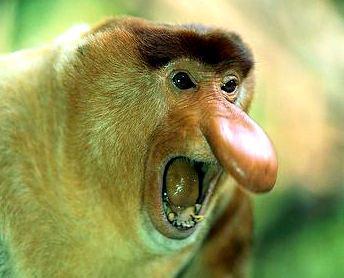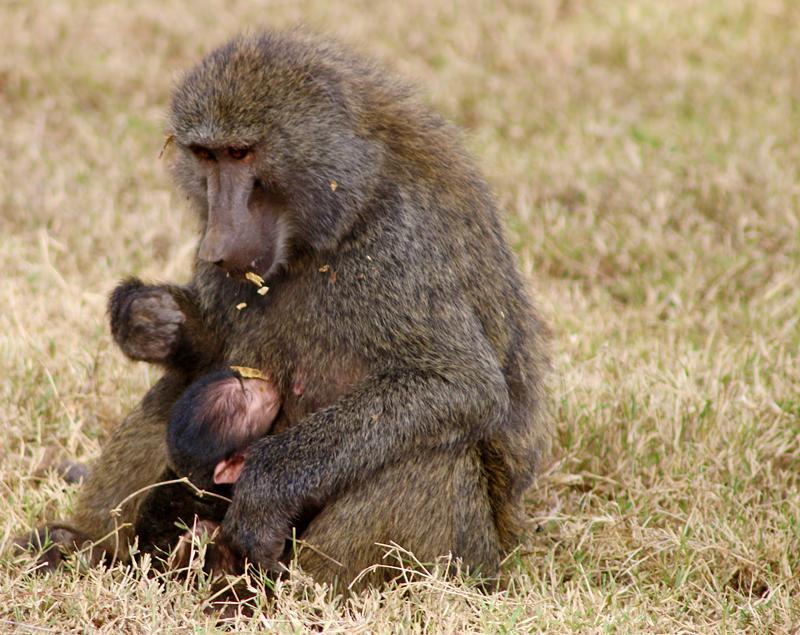The first image is the image on the left, the second image is the image on the right. Assess this claim about the two images: "There is more than one monkey in the left image.". Correct or not? Answer yes or no. No. The first image is the image on the left, the second image is the image on the right. Given the left and right images, does the statement "At least one of the animals is showing its teeth." hold true? Answer yes or no. Yes. 